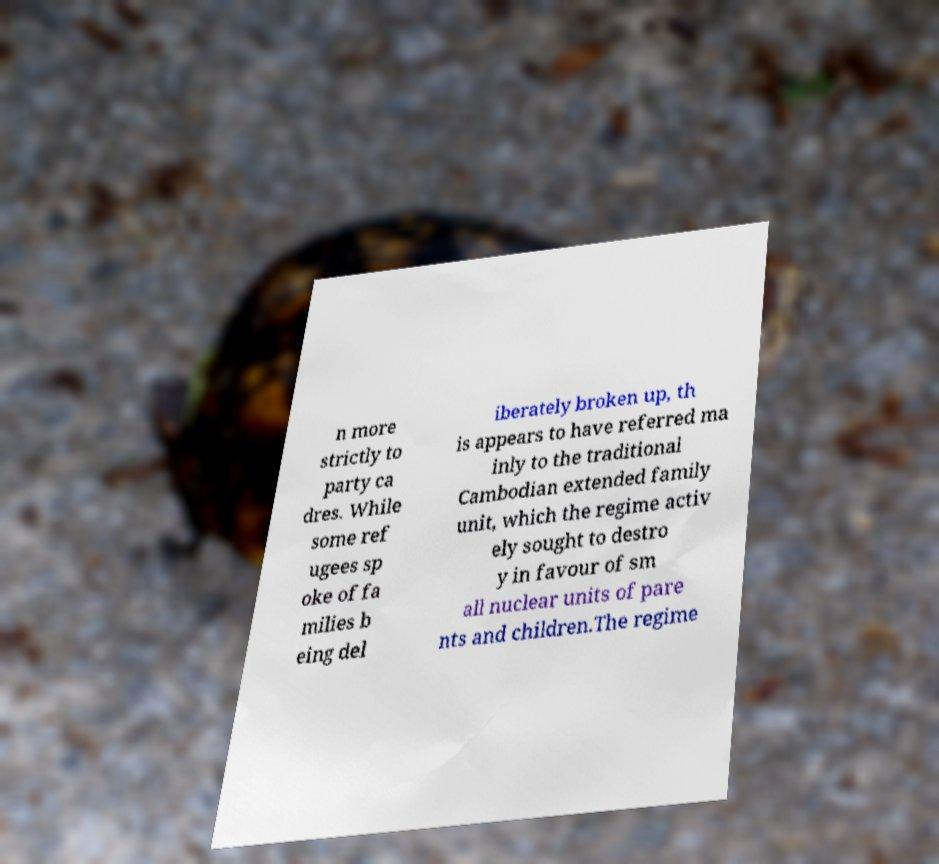For documentation purposes, I need the text within this image transcribed. Could you provide that? n more strictly to party ca dres. While some ref ugees sp oke of fa milies b eing del iberately broken up, th is appears to have referred ma inly to the traditional Cambodian extended family unit, which the regime activ ely sought to destro y in favour of sm all nuclear units of pare nts and children.The regime 